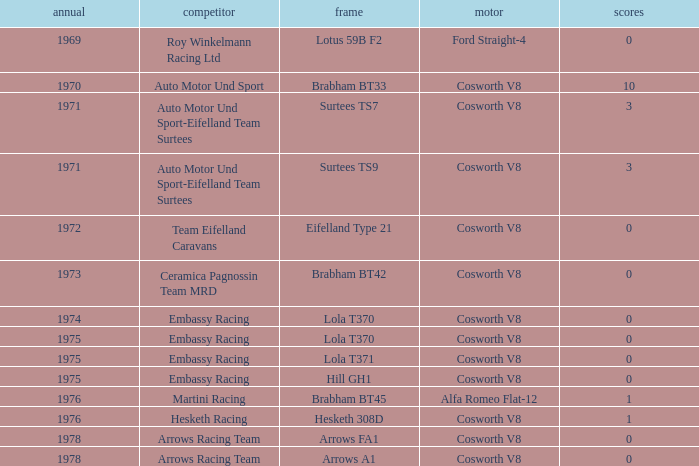What was the total amount of points in 1978 with a Chassis of arrows fa1? 0.0. 